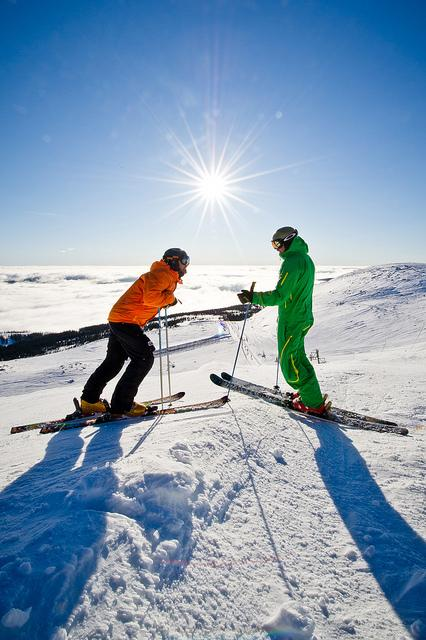What part of the world are the skiers most likely in?

Choices:
A) south america
B) antarctica
C) colorado
D) india colorado 